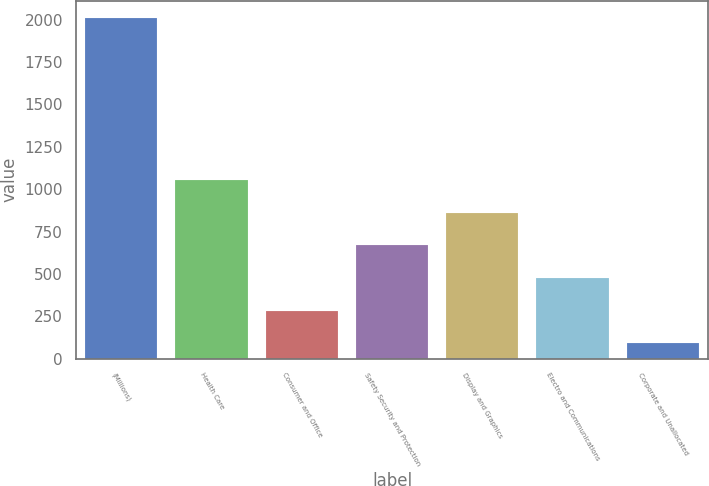<chart> <loc_0><loc_0><loc_500><loc_500><bar_chart><fcel>(Millions)<fcel>Health Care<fcel>Consumer and Office<fcel>Safety Security and Protection<fcel>Display and Graphics<fcel>Electro and Communications<fcel>Corporate and Unallocated<nl><fcel>2011<fcel>1051.5<fcel>283.9<fcel>667.7<fcel>859.6<fcel>475.8<fcel>92<nl></chart> 